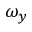Convert formula to latex. <formula><loc_0><loc_0><loc_500><loc_500>\omega _ { y }</formula> 